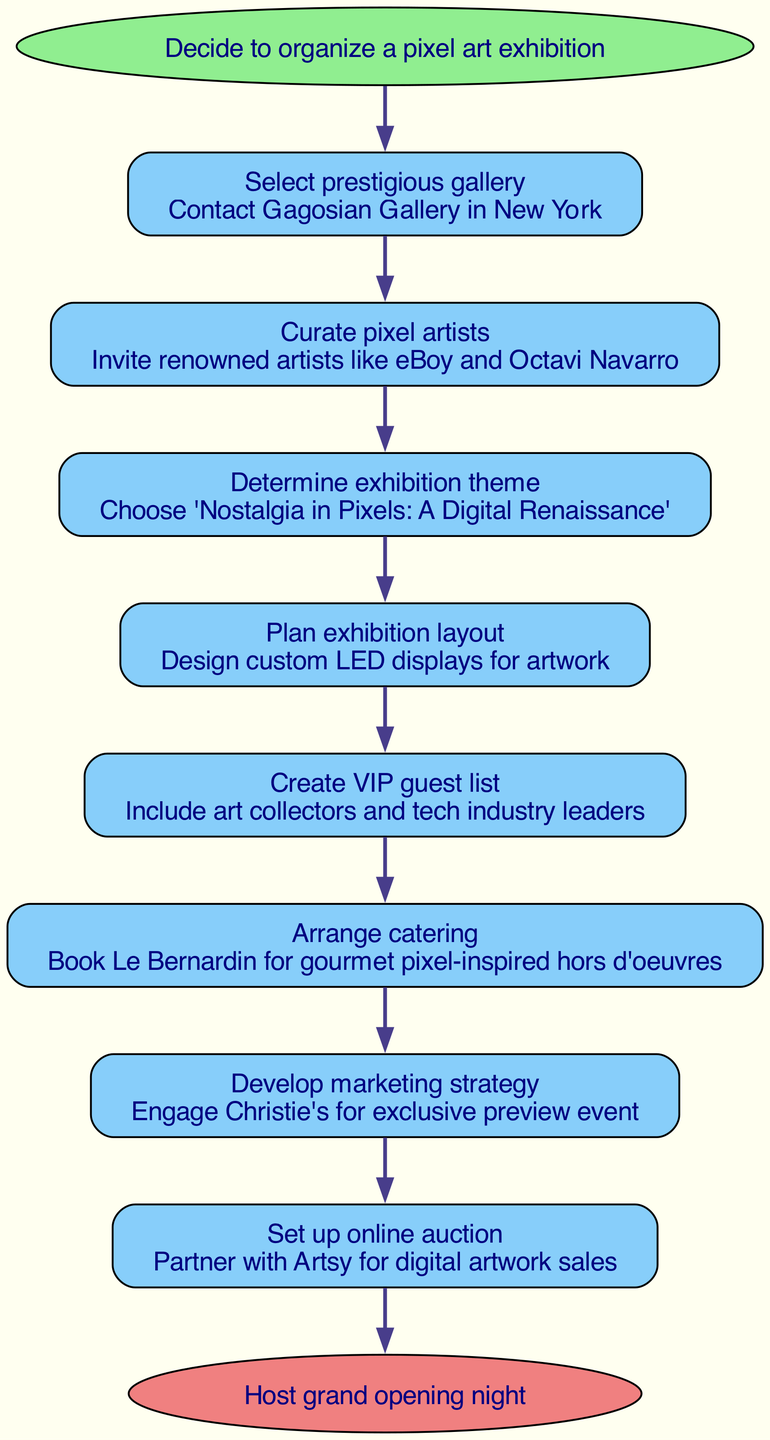What is the starting point of the flow chart? The starting point of the flow chart is labeled as "Decide to organize a pixel art exhibition." This is the initial step from which all other actions branch out.
Answer: Decide to organize a pixel art exhibition How many steps are included in the flow chart? There are a total of 8 steps listed in the flow chart that outline the process for organizing the exhibition. Each step corresponds to a particular action that follows the previous one.
Answer: 8 What is the next step after selecting the prestigious gallery? After selecting the prestigious gallery, the next step is to "Contact Gagosian Gallery in New York." This indicates a direct action taken in the organization process.
Answer: Contact Gagosian Gallery in New York What is the end point of the flow chart? The end point of the flow chart is labeled as "Host grand opening night," indicating the final outcome of following all the prior steps in the exhibition organization process.
Answer: Host grand opening night Which step involves creating a guest list? The step that involves creating a guest list is "Create VIP guest list." This step specifies the action of compiling notable attendees for the exhibition.
Answer: Create VIP guest list What is the third step in the flow chart? The third step in the flow chart is "Determine exhibition theme," showing that establishing a unifying concept is an essential part of the organization.
Answer: Determine exhibition theme How does arranging catering correlate with the guest list? Arranging catering is directly related to the guest list as it requires planning gourmet offerings suitable for the VIP guests that will be attending the event, represented by "Book Le Bernardin for gourmet pixel-inspired hors d'oeuvres."
Answer: Book Le Bernardin for gourmet pixel-inspired hors d'oeuvres Which artist is invited in the curation step? The artist invited in the curation step is "eBoy," indicating that this renowned pixel artist is part of the lineup for the exhibition, further emphasizing the quality of the showcased work.
Answer: eBoy 